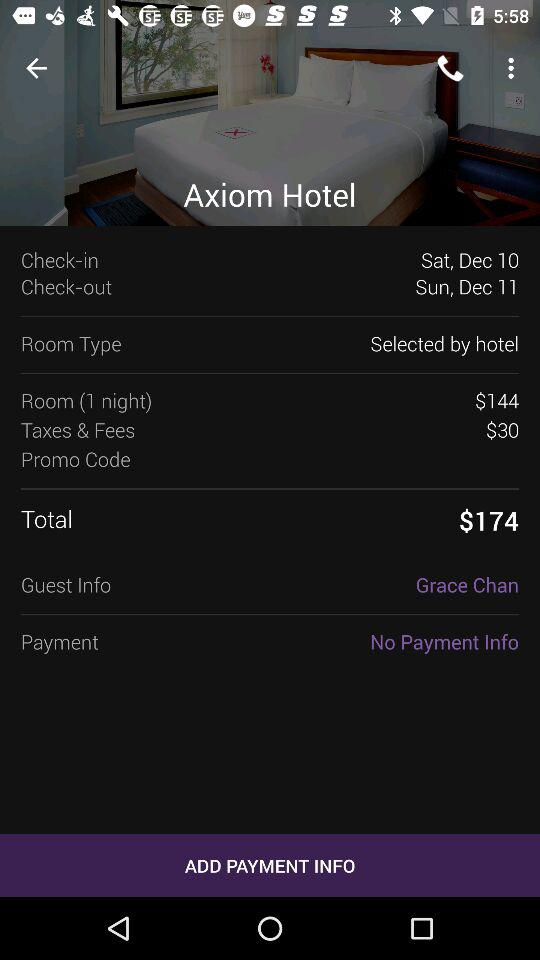How much more is the room than the taxes and fees?
Answer the question using a single word or phrase. $114 